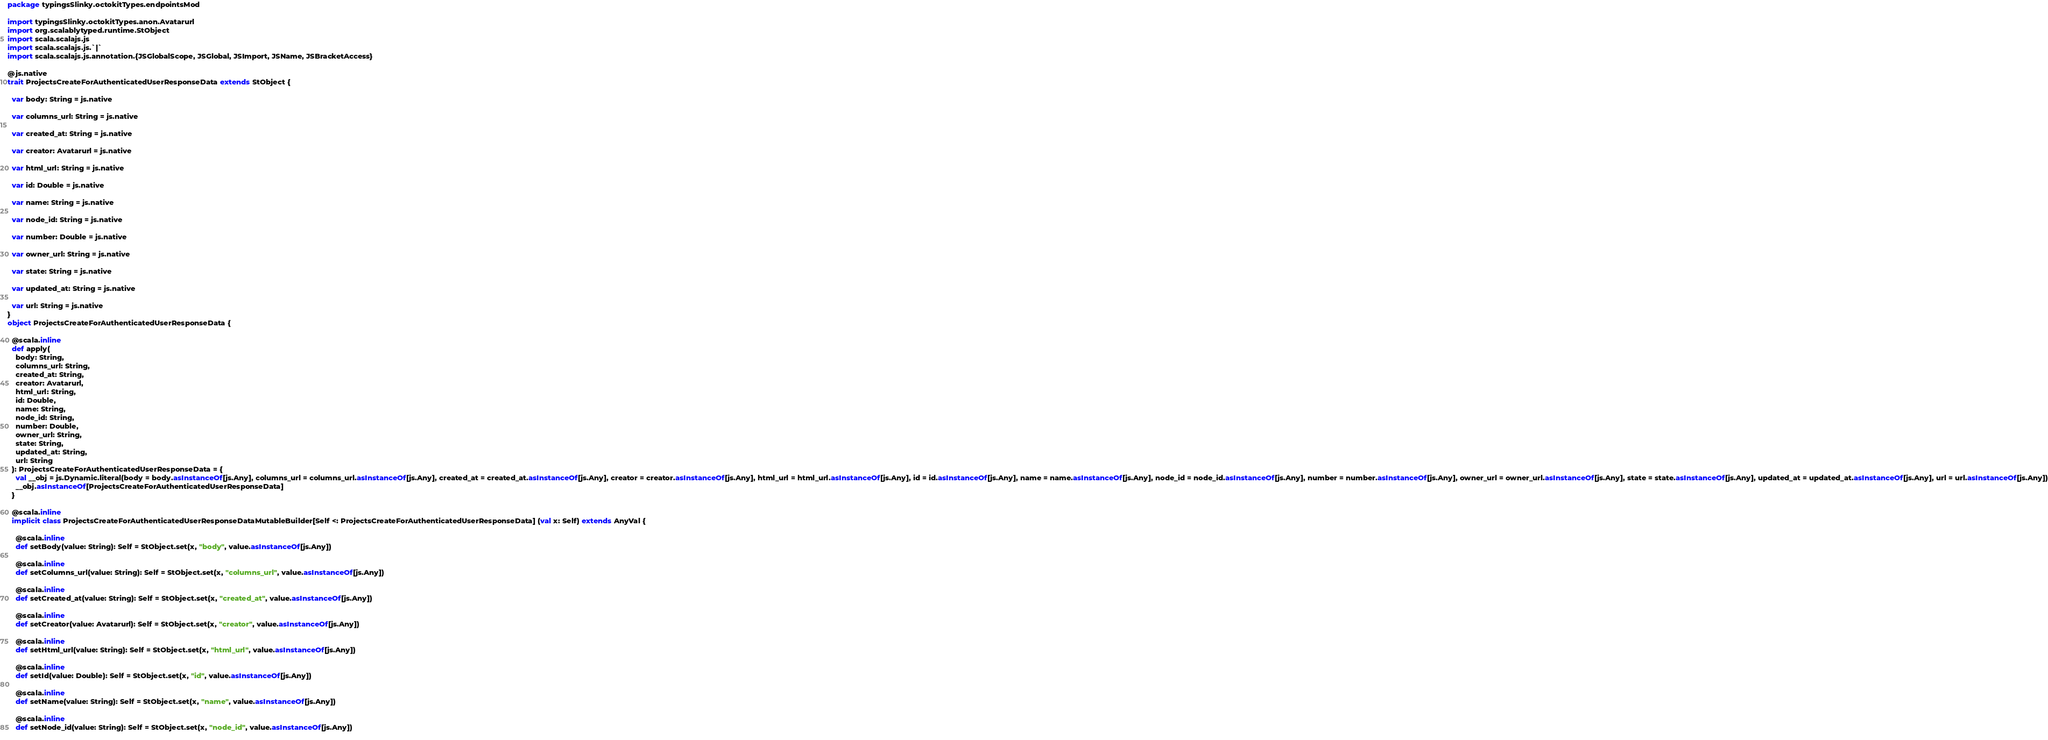Convert code to text. <code><loc_0><loc_0><loc_500><loc_500><_Scala_>package typingsSlinky.octokitTypes.endpointsMod

import typingsSlinky.octokitTypes.anon.Avatarurl
import org.scalablytyped.runtime.StObject
import scala.scalajs.js
import scala.scalajs.js.`|`
import scala.scalajs.js.annotation.{JSGlobalScope, JSGlobal, JSImport, JSName, JSBracketAccess}

@js.native
trait ProjectsCreateForAuthenticatedUserResponseData extends StObject {
  
  var body: String = js.native
  
  var columns_url: String = js.native
  
  var created_at: String = js.native
  
  var creator: Avatarurl = js.native
  
  var html_url: String = js.native
  
  var id: Double = js.native
  
  var name: String = js.native
  
  var node_id: String = js.native
  
  var number: Double = js.native
  
  var owner_url: String = js.native
  
  var state: String = js.native
  
  var updated_at: String = js.native
  
  var url: String = js.native
}
object ProjectsCreateForAuthenticatedUserResponseData {
  
  @scala.inline
  def apply(
    body: String,
    columns_url: String,
    created_at: String,
    creator: Avatarurl,
    html_url: String,
    id: Double,
    name: String,
    node_id: String,
    number: Double,
    owner_url: String,
    state: String,
    updated_at: String,
    url: String
  ): ProjectsCreateForAuthenticatedUserResponseData = {
    val __obj = js.Dynamic.literal(body = body.asInstanceOf[js.Any], columns_url = columns_url.asInstanceOf[js.Any], created_at = created_at.asInstanceOf[js.Any], creator = creator.asInstanceOf[js.Any], html_url = html_url.asInstanceOf[js.Any], id = id.asInstanceOf[js.Any], name = name.asInstanceOf[js.Any], node_id = node_id.asInstanceOf[js.Any], number = number.asInstanceOf[js.Any], owner_url = owner_url.asInstanceOf[js.Any], state = state.asInstanceOf[js.Any], updated_at = updated_at.asInstanceOf[js.Any], url = url.asInstanceOf[js.Any])
    __obj.asInstanceOf[ProjectsCreateForAuthenticatedUserResponseData]
  }
  
  @scala.inline
  implicit class ProjectsCreateForAuthenticatedUserResponseDataMutableBuilder[Self <: ProjectsCreateForAuthenticatedUserResponseData] (val x: Self) extends AnyVal {
    
    @scala.inline
    def setBody(value: String): Self = StObject.set(x, "body", value.asInstanceOf[js.Any])
    
    @scala.inline
    def setColumns_url(value: String): Self = StObject.set(x, "columns_url", value.asInstanceOf[js.Any])
    
    @scala.inline
    def setCreated_at(value: String): Self = StObject.set(x, "created_at", value.asInstanceOf[js.Any])
    
    @scala.inline
    def setCreator(value: Avatarurl): Self = StObject.set(x, "creator", value.asInstanceOf[js.Any])
    
    @scala.inline
    def setHtml_url(value: String): Self = StObject.set(x, "html_url", value.asInstanceOf[js.Any])
    
    @scala.inline
    def setId(value: Double): Self = StObject.set(x, "id", value.asInstanceOf[js.Any])
    
    @scala.inline
    def setName(value: String): Self = StObject.set(x, "name", value.asInstanceOf[js.Any])
    
    @scala.inline
    def setNode_id(value: String): Self = StObject.set(x, "node_id", value.asInstanceOf[js.Any])
    </code> 